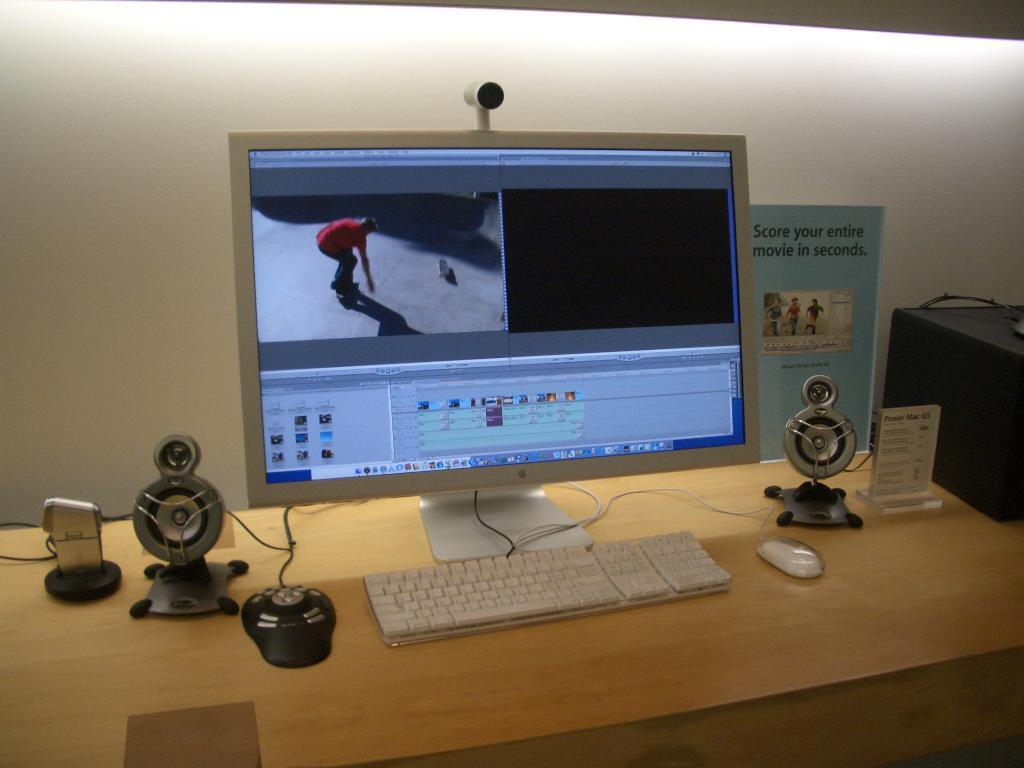<image>
Render a clear and concise summary of the photo. A computer is on a table next a a flyer that says score your entire movie in seconds. 